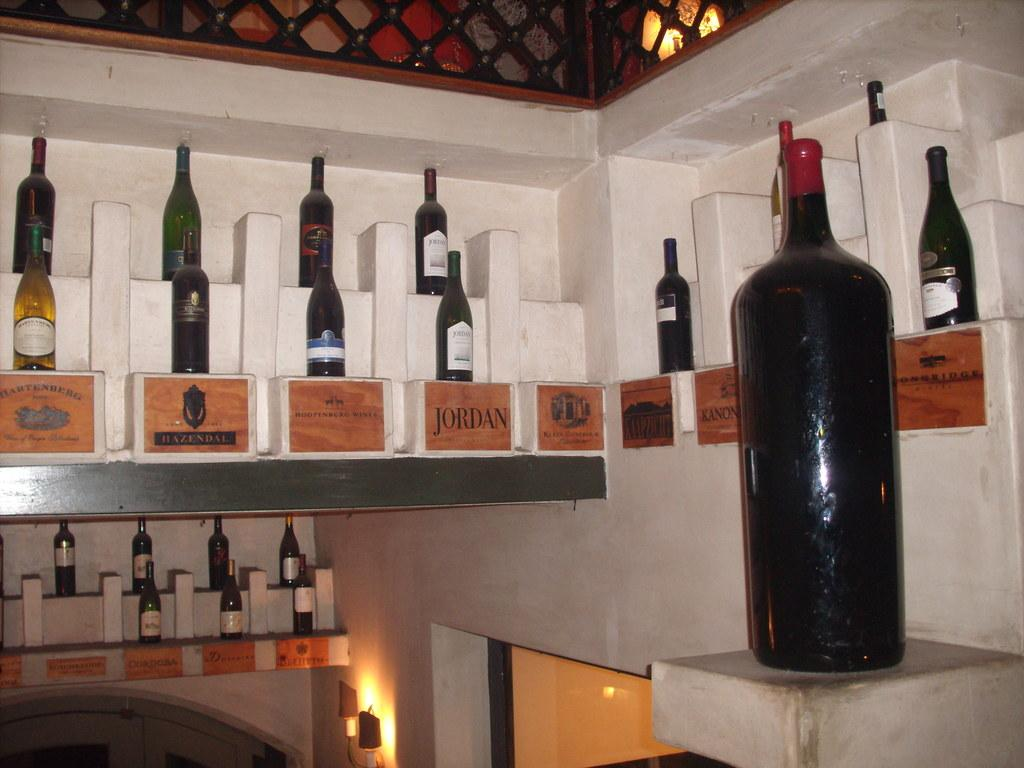<image>
Summarize the visual content of the image. Shelves of wine bottles on display with wooden plaques that state what type of wine is on the shelve like the Jordan brand. 